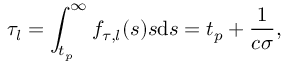<formula> <loc_0><loc_0><loc_500><loc_500>\tau _ { l } = \int _ { t _ { p } } ^ { \infty } f _ { \tau , l } ( s ) s d s = t _ { p } + \frac { 1 } { c \sigma } ,</formula> 